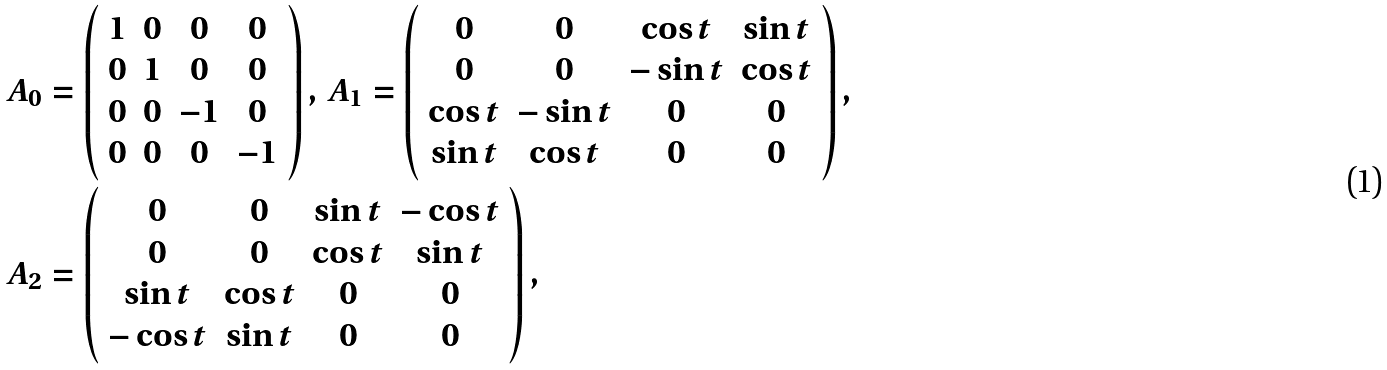<formula> <loc_0><loc_0><loc_500><loc_500>& A _ { 0 } = \left ( \begin{array} { c c c c } 1 & 0 & 0 & 0 \\ 0 & 1 & 0 & 0 \\ 0 & 0 & - 1 & 0 \\ 0 & 0 & 0 & - 1 \end{array} \right ) , \, A _ { 1 } = \left ( \begin{array} { c c c c } 0 & 0 & \cos t & \sin t \\ 0 & 0 & - \sin t & \cos t \\ \cos t & - \sin t & 0 & 0 \\ \sin t & \cos t & 0 & 0 \end{array} \right ) , \\ & A _ { 2 } = \left ( \begin{array} { c c c c } 0 & 0 & \sin t & - \cos t \\ 0 & 0 & \cos t & \sin t \\ \sin t & \cos t & 0 & 0 \\ - \cos t & \sin t & 0 & 0 \end{array} \right ) ,</formula> 